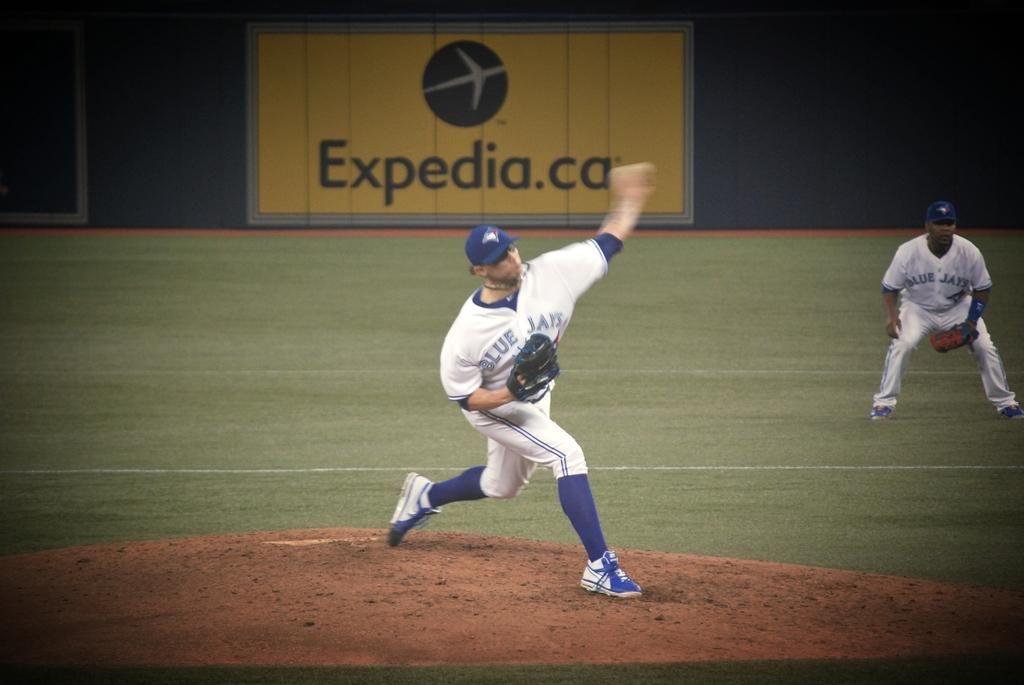<image>
Share a concise interpretation of the image provided. Man wearing a Blue Jays jersey about to pitch. 